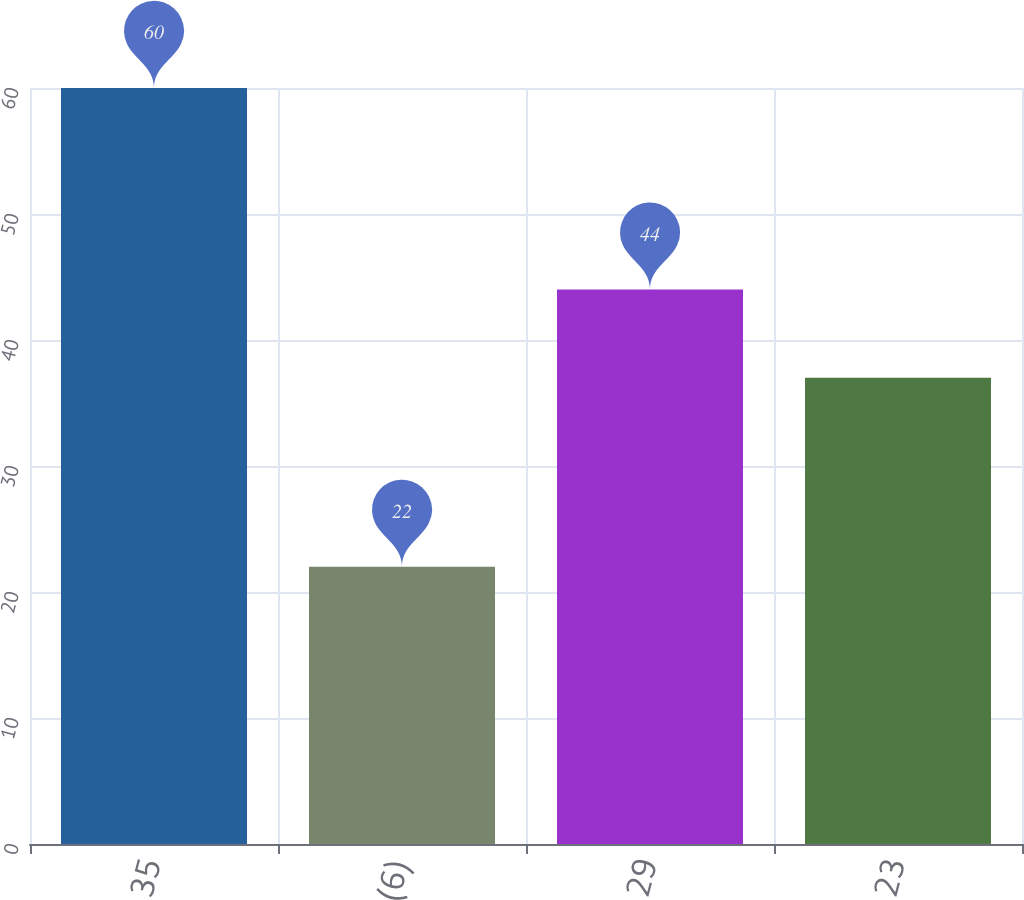Convert chart. <chart><loc_0><loc_0><loc_500><loc_500><bar_chart><fcel>35<fcel>(6)<fcel>29<fcel>23<nl><fcel>60<fcel>22<fcel>44<fcel>37<nl></chart> 